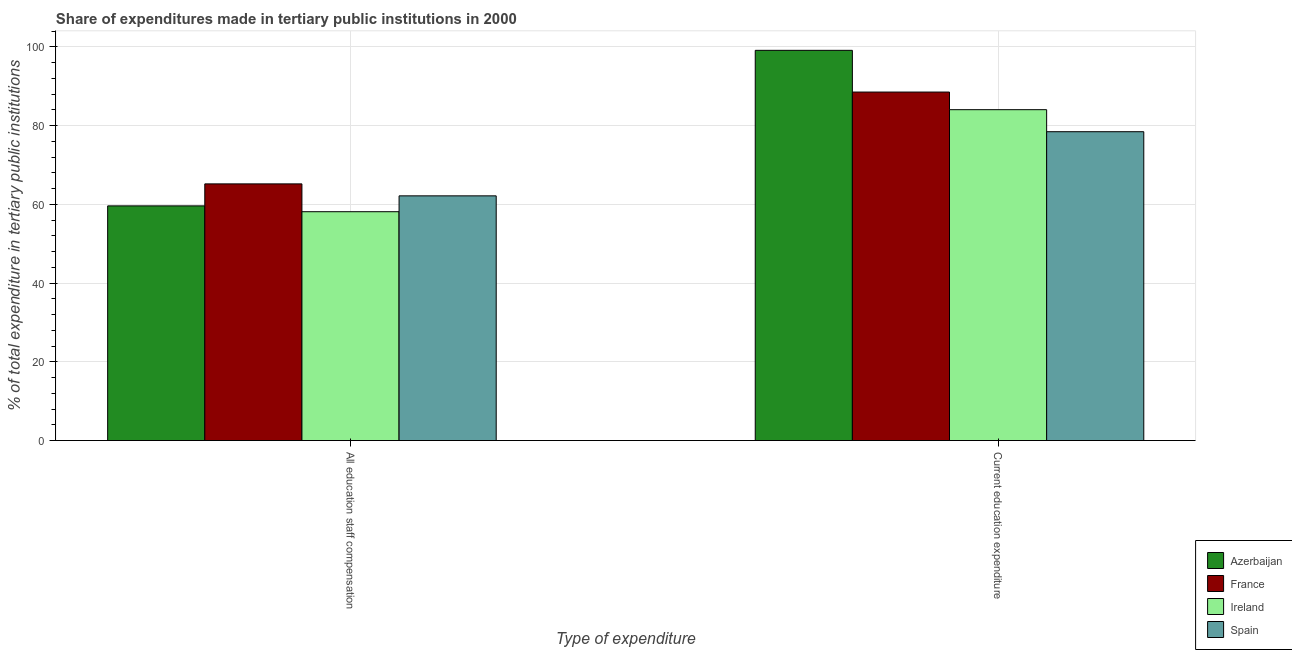How many different coloured bars are there?
Your answer should be compact. 4. How many bars are there on the 1st tick from the left?
Offer a terse response. 4. What is the label of the 2nd group of bars from the left?
Ensure brevity in your answer.  Current education expenditure. What is the expenditure in staff compensation in Spain?
Offer a very short reply. 62.15. Across all countries, what is the maximum expenditure in staff compensation?
Your response must be concise. 65.19. Across all countries, what is the minimum expenditure in education?
Give a very brief answer. 78.44. In which country was the expenditure in staff compensation maximum?
Ensure brevity in your answer.  France. In which country was the expenditure in staff compensation minimum?
Provide a short and direct response. Ireland. What is the total expenditure in staff compensation in the graph?
Provide a succinct answer. 245.06. What is the difference between the expenditure in education in Spain and that in Ireland?
Keep it short and to the point. -5.6. What is the difference between the expenditure in staff compensation in Ireland and the expenditure in education in Spain?
Offer a terse response. -20.32. What is the average expenditure in education per country?
Your answer should be very brief. 87.52. What is the difference between the expenditure in education and expenditure in staff compensation in Spain?
Give a very brief answer. 16.29. In how many countries, is the expenditure in staff compensation greater than 92 %?
Ensure brevity in your answer.  0. What is the ratio of the expenditure in education in Spain to that in Ireland?
Ensure brevity in your answer.  0.93. Is the expenditure in staff compensation in France less than that in Spain?
Make the answer very short. No. What does the 4th bar from the right in All education staff compensation represents?
Provide a succinct answer. Azerbaijan. How many bars are there?
Your answer should be compact. 8. How many countries are there in the graph?
Your answer should be compact. 4. What is the difference between two consecutive major ticks on the Y-axis?
Your response must be concise. 20. Are the values on the major ticks of Y-axis written in scientific E-notation?
Offer a very short reply. No. Does the graph contain any zero values?
Provide a short and direct response. No. Where does the legend appear in the graph?
Your answer should be compact. Bottom right. What is the title of the graph?
Provide a short and direct response. Share of expenditures made in tertiary public institutions in 2000. What is the label or title of the X-axis?
Keep it short and to the point. Type of expenditure. What is the label or title of the Y-axis?
Give a very brief answer. % of total expenditure in tertiary public institutions. What is the % of total expenditure in tertiary public institutions of Azerbaijan in All education staff compensation?
Your response must be concise. 59.6. What is the % of total expenditure in tertiary public institutions of France in All education staff compensation?
Make the answer very short. 65.19. What is the % of total expenditure in tertiary public institutions of Ireland in All education staff compensation?
Provide a succinct answer. 58.12. What is the % of total expenditure in tertiary public institutions in Spain in All education staff compensation?
Provide a short and direct response. 62.15. What is the % of total expenditure in tertiary public institutions of Azerbaijan in Current education expenditure?
Ensure brevity in your answer.  99.1. What is the % of total expenditure in tertiary public institutions in France in Current education expenditure?
Offer a terse response. 88.51. What is the % of total expenditure in tertiary public institutions in Ireland in Current education expenditure?
Ensure brevity in your answer.  84.03. What is the % of total expenditure in tertiary public institutions of Spain in Current education expenditure?
Provide a succinct answer. 78.44. Across all Type of expenditure, what is the maximum % of total expenditure in tertiary public institutions of Azerbaijan?
Ensure brevity in your answer.  99.1. Across all Type of expenditure, what is the maximum % of total expenditure in tertiary public institutions of France?
Provide a succinct answer. 88.51. Across all Type of expenditure, what is the maximum % of total expenditure in tertiary public institutions in Ireland?
Your answer should be very brief. 84.03. Across all Type of expenditure, what is the maximum % of total expenditure in tertiary public institutions in Spain?
Ensure brevity in your answer.  78.44. Across all Type of expenditure, what is the minimum % of total expenditure in tertiary public institutions in Azerbaijan?
Your answer should be very brief. 59.6. Across all Type of expenditure, what is the minimum % of total expenditure in tertiary public institutions of France?
Offer a terse response. 65.19. Across all Type of expenditure, what is the minimum % of total expenditure in tertiary public institutions in Ireland?
Your answer should be compact. 58.12. Across all Type of expenditure, what is the minimum % of total expenditure in tertiary public institutions of Spain?
Provide a succinct answer. 62.15. What is the total % of total expenditure in tertiary public institutions of Azerbaijan in the graph?
Make the answer very short. 158.7. What is the total % of total expenditure in tertiary public institutions of France in the graph?
Give a very brief answer. 153.7. What is the total % of total expenditure in tertiary public institutions of Ireland in the graph?
Offer a very short reply. 142.15. What is the total % of total expenditure in tertiary public institutions of Spain in the graph?
Ensure brevity in your answer.  140.59. What is the difference between the % of total expenditure in tertiary public institutions of Azerbaijan in All education staff compensation and that in Current education expenditure?
Your answer should be very brief. -39.5. What is the difference between the % of total expenditure in tertiary public institutions of France in All education staff compensation and that in Current education expenditure?
Ensure brevity in your answer.  -23.32. What is the difference between the % of total expenditure in tertiary public institutions of Ireland in All education staff compensation and that in Current education expenditure?
Your response must be concise. -25.91. What is the difference between the % of total expenditure in tertiary public institutions in Spain in All education staff compensation and that in Current education expenditure?
Offer a terse response. -16.29. What is the difference between the % of total expenditure in tertiary public institutions in Azerbaijan in All education staff compensation and the % of total expenditure in tertiary public institutions in France in Current education expenditure?
Your response must be concise. -28.91. What is the difference between the % of total expenditure in tertiary public institutions in Azerbaijan in All education staff compensation and the % of total expenditure in tertiary public institutions in Ireland in Current education expenditure?
Give a very brief answer. -24.43. What is the difference between the % of total expenditure in tertiary public institutions in Azerbaijan in All education staff compensation and the % of total expenditure in tertiary public institutions in Spain in Current education expenditure?
Provide a short and direct response. -18.84. What is the difference between the % of total expenditure in tertiary public institutions in France in All education staff compensation and the % of total expenditure in tertiary public institutions in Ireland in Current education expenditure?
Offer a terse response. -18.85. What is the difference between the % of total expenditure in tertiary public institutions in France in All education staff compensation and the % of total expenditure in tertiary public institutions in Spain in Current education expenditure?
Ensure brevity in your answer.  -13.25. What is the difference between the % of total expenditure in tertiary public institutions in Ireland in All education staff compensation and the % of total expenditure in tertiary public institutions in Spain in Current education expenditure?
Your answer should be compact. -20.32. What is the average % of total expenditure in tertiary public institutions of Azerbaijan per Type of expenditure?
Offer a very short reply. 79.35. What is the average % of total expenditure in tertiary public institutions in France per Type of expenditure?
Give a very brief answer. 76.85. What is the average % of total expenditure in tertiary public institutions of Ireland per Type of expenditure?
Give a very brief answer. 71.08. What is the average % of total expenditure in tertiary public institutions of Spain per Type of expenditure?
Keep it short and to the point. 70.29. What is the difference between the % of total expenditure in tertiary public institutions of Azerbaijan and % of total expenditure in tertiary public institutions of France in All education staff compensation?
Offer a terse response. -5.59. What is the difference between the % of total expenditure in tertiary public institutions in Azerbaijan and % of total expenditure in tertiary public institutions in Ireland in All education staff compensation?
Your response must be concise. 1.48. What is the difference between the % of total expenditure in tertiary public institutions in Azerbaijan and % of total expenditure in tertiary public institutions in Spain in All education staff compensation?
Keep it short and to the point. -2.55. What is the difference between the % of total expenditure in tertiary public institutions of France and % of total expenditure in tertiary public institutions of Ireland in All education staff compensation?
Offer a terse response. 7.07. What is the difference between the % of total expenditure in tertiary public institutions in France and % of total expenditure in tertiary public institutions in Spain in All education staff compensation?
Provide a succinct answer. 3.04. What is the difference between the % of total expenditure in tertiary public institutions in Ireland and % of total expenditure in tertiary public institutions in Spain in All education staff compensation?
Keep it short and to the point. -4.03. What is the difference between the % of total expenditure in tertiary public institutions in Azerbaijan and % of total expenditure in tertiary public institutions in France in Current education expenditure?
Your answer should be compact. 10.6. What is the difference between the % of total expenditure in tertiary public institutions of Azerbaijan and % of total expenditure in tertiary public institutions of Ireland in Current education expenditure?
Offer a terse response. 15.07. What is the difference between the % of total expenditure in tertiary public institutions of Azerbaijan and % of total expenditure in tertiary public institutions of Spain in Current education expenditure?
Offer a very short reply. 20.66. What is the difference between the % of total expenditure in tertiary public institutions of France and % of total expenditure in tertiary public institutions of Ireland in Current education expenditure?
Provide a succinct answer. 4.47. What is the difference between the % of total expenditure in tertiary public institutions of France and % of total expenditure in tertiary public institutions of Spain in Current education expenditure?
Offer a terse response. 10.07. What is the difference between the % of total expenditure in tertiary public institutions in Ireland and % of total expenditure in tertiary public institutions in Spain in Current education expenditure?
Your answer should be compact. 5.6. What is the ratio of the % of total expenditure in tertiary public institutions in Azerbaijan in All education staff compensation to that in Current education expenditure?
Your answer should be compact. 0.6. What is the ratio of the % of total expenditure in tertiary public institutions of France in All education staff compensation to that in Current education expenditure?
Your answer should be very brief. 0.74. What is the ratio of the % of total expenditure in tertiary public institutions in Ireland in All education staff compensation to that in Current education expenditure?
Your response must be concise. 0.69. What is the ratio of the % of total expenditure in tertiary public institutions of Spain in All education staff compensation to that in Current education expenditure?
Keep it short and to the point. 0.79. What is the difference between the highest and the second highest % of total expenditure in tertiary public institutions of Azerbaijan?
Give a very brief answer. 39.5. What is the difference between the highest and the second highest % of total expenditure in tertiary public institutions of France?
Ensure brevity in your answer.  23.32. What is the difference between the highest and the second highest % of total expenditure in tertiary public institutions of Ireland?
Make the answer very short. 25.91. What is the difference between the highest and the second highest % of total expenditure in tertiary public institutions of Spain?
Provide a succinct answer. 16.29. What is the difference between the highest and the lowest % of total expenditure in tertiary public institutions in Azerbaijan?
Give a very brief answer. 39.5. What is the difference between the highest and the lowest % of total expenditure in tertiary public institutions of France?
Ensure brevity in your answer.  23.32. What is the difference between the highest and the lowest % of total expenditure in tertiary public institutions in Ireland?
Ensure brevity in your answer.  25.91. What is the difference between the highest and the lowest % of total expenditure in tertiary public institutions in Spain?
Make the answer very short. 16.29. 